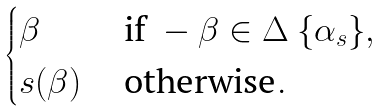Convert formula to latex. <formula><loc_0><loc_0><loc_500><loc_500>\begin{cases} \beta & \text { if } - \beta \in \Delta \ \{ \alpha _ { s } \} , \\ s ( \beta ) & \text { otherwise} . \\ \end{cases}</formula> 